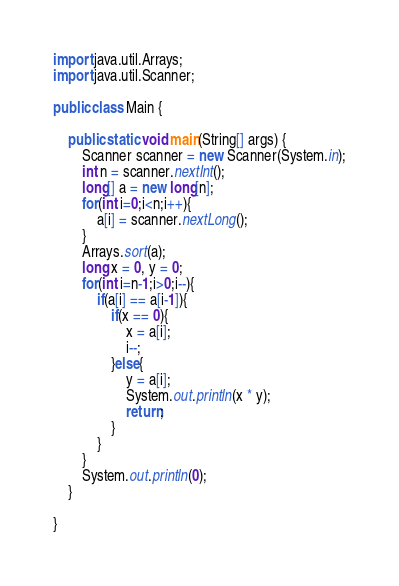<code> <loc_0><loc_0><loc_500><loc_500><_Java_>import java.util.Arrays;
import java.util.Scanner;

public class Main {

	public static void main(String[] args) {
		Scanner scanner = new Scanner(System.in);
		int n = scanner.nextInt();
		long[] a = new long[n];
		for(int i=0;i<n;i++){
			a[i] = scanner.nextLong();
		}
		Arrays.sort(a);
		long x = 0, y = 0;
		for(int i=n-1;i>0;i--){
			if(a[i] == a[i-1]){
				if(x == 0){
					x = a[i];
					i--;
				}else{
					y = a[i];
					System.out.println(x * y);
					return;
				}
			}
		}
		System.out.println(0);
	}

}
</code> 